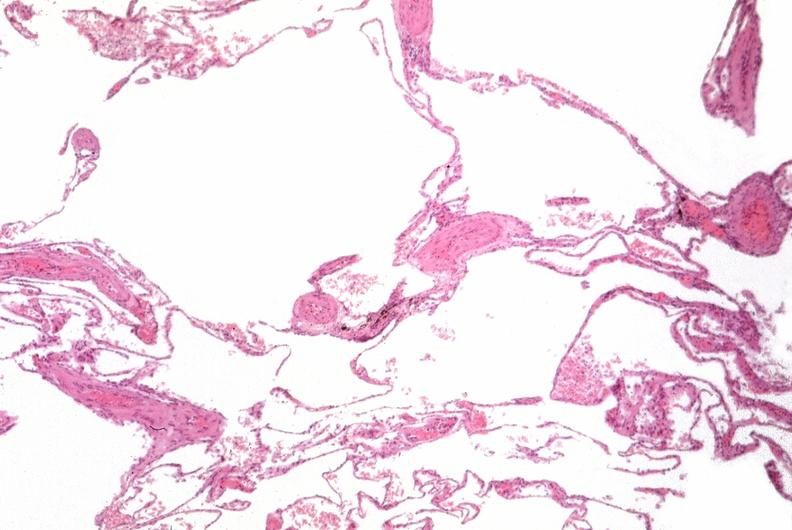does calculi show lung, emphysema, alpha-1 antitrypsin deficiency?
Answer the question using a single word or phrase. No 